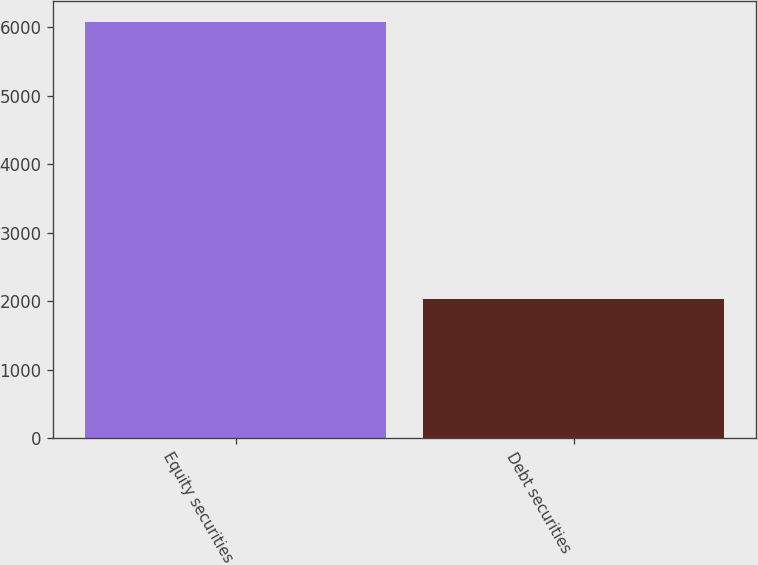Convert chart. <chart><loc_0><loc_0><loc_500><loc_500><bar_chart><fcel>Equity securities<fcel>Debt securities<nl><fcel>6080<fcel>2030<nl></chart> 